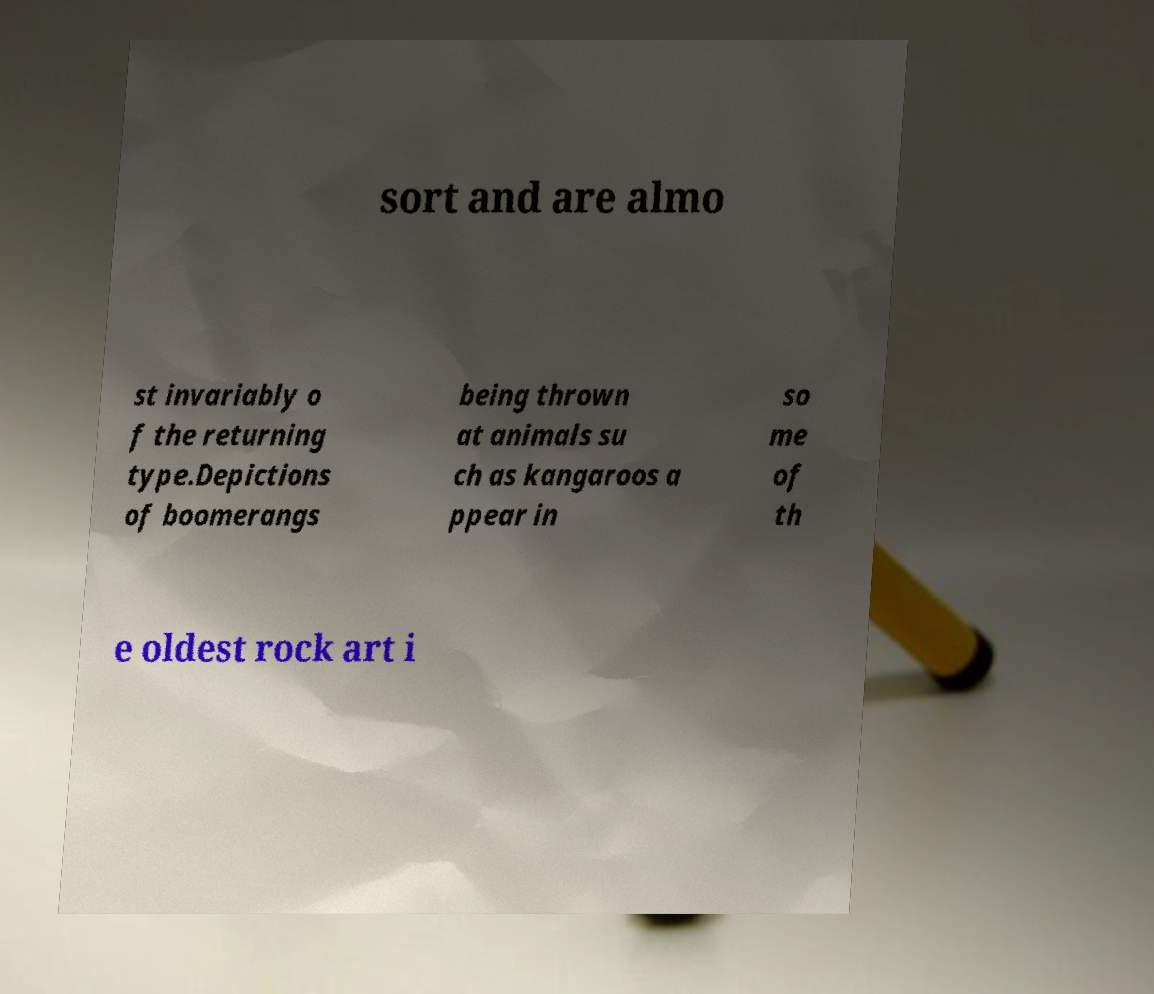Please identify and transcribe the text found in this image. sort and are almo st invariably o f the returning type.Depictions of boomerangs being thrown at animals su ch as kangaroos a ppear in so me of th e oldest rock art i 